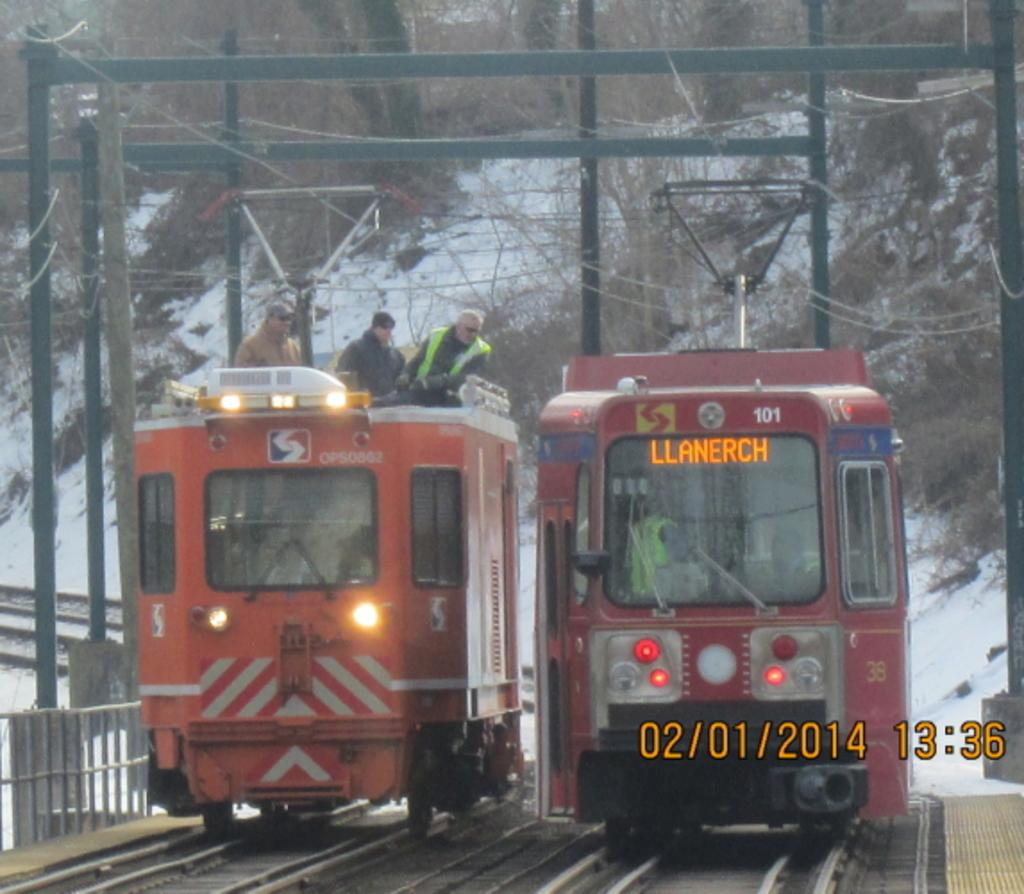Provide a one-sentence caption for the provided image. Two trains moving next to each other, one is heading to Llanerch. 